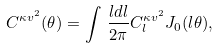Convert formula to latex. <formula><loc_0><loc_0><loc_500><loc_500>C ^ { \kappa v ^ { 2 } } ( \theta ) = \int \, \frac { l d l } { 2 \pi } C _ { l } ^ { \kappa v ^ { 2 } } J _ { 0 } ( l \theta ) ,</formula> 